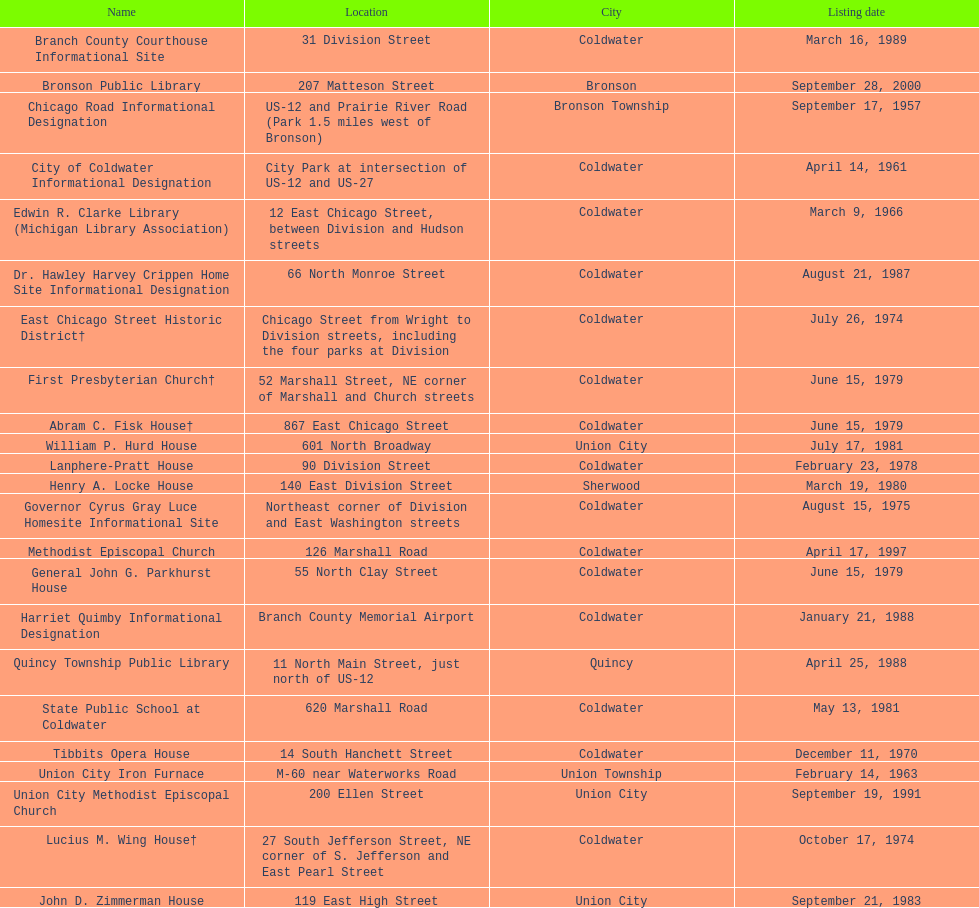In coldwater, how many sites can be found? 15. 